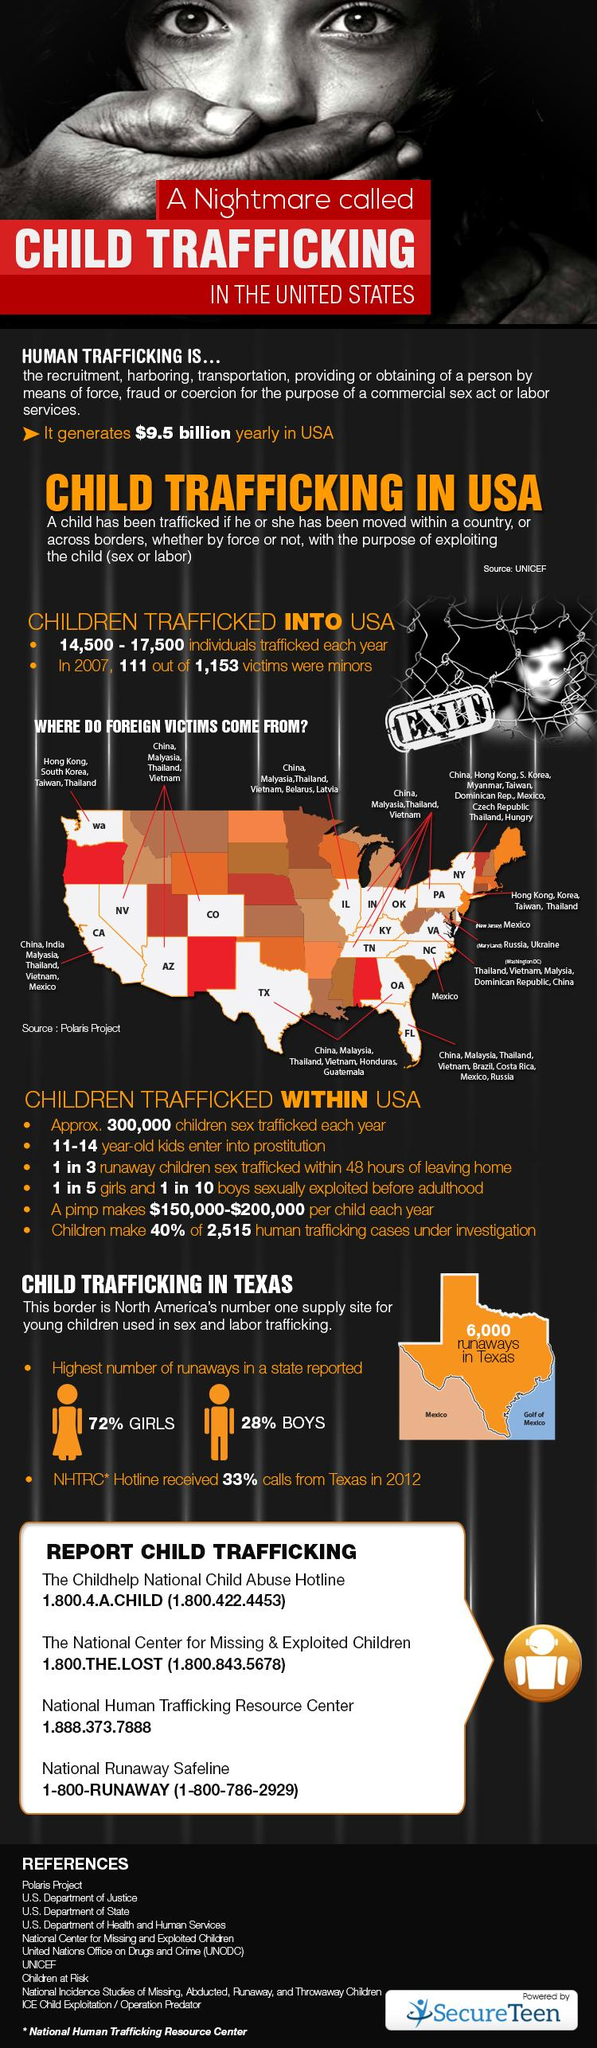Outline some significant characteristics in this image. In 2012, the state with the highest number of reported cases was Texas. Four helpline numbers have been provided. 